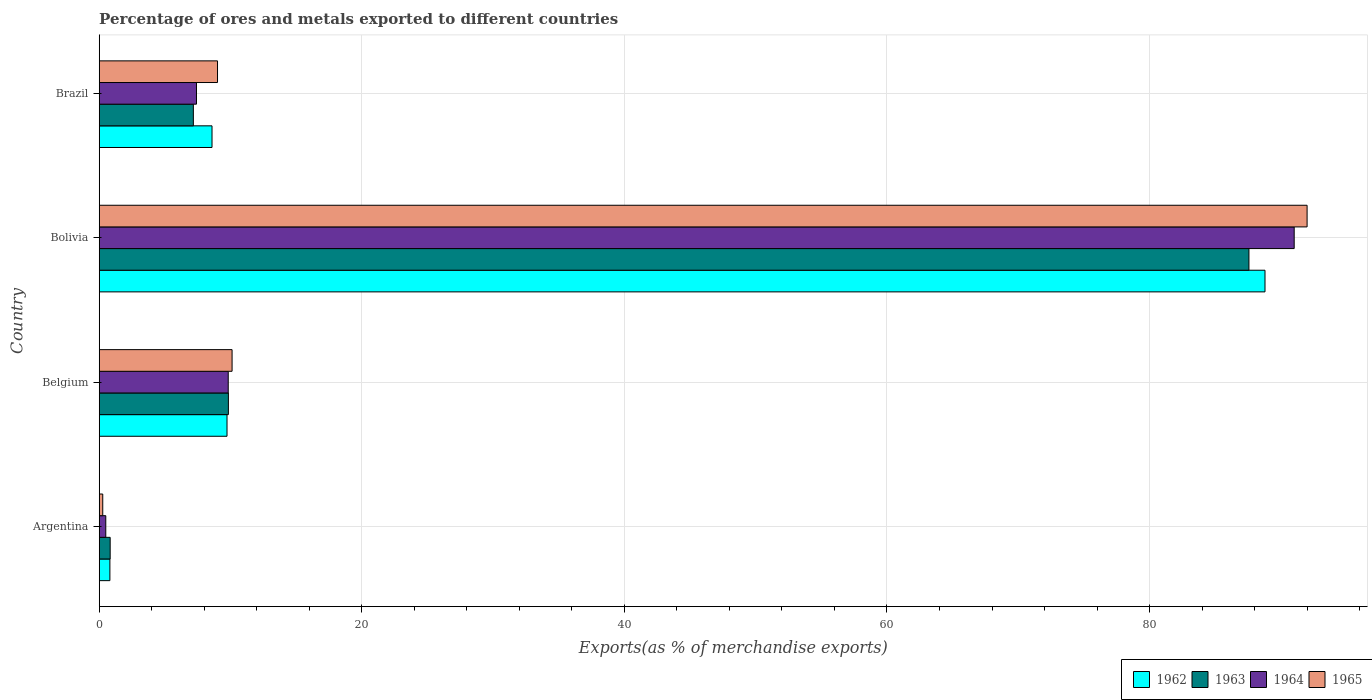How many groups of bars are there?
Offer a very short reply. 4. Are the number of bars per tick equal to the number of legend labels?
Your response must be concise. Yes. Are the number of bars on each tick of the Y-axis equal?
Ensure brevity in your answer.  Yes. How many bars are there on the 3rd tick from the bottom?
Provide a short and direct response. 4. What is the percentage of exports to different countries in 1964 in Argentina?
Offer a terse response. 0.5. Across all countries, what is the maximum percentage of exports to different countries in 1963?
Keep it short and to the point. 87.57. Across all countries, what is the minimum percentage of exports to different countries in 1962?
Give a very brief answer. 0.81. In which country was the percentage of exports to different countries in 1965 maximum?
Offer a terse response. Bolivia. What is the total percentage of exports to different countries in 1964 in the graph?
Ensure brevity in your answer.  108.75. What is the difference between the percentage of exports to different countries in 1965 in Belgium and that in Brazil?
Give a very brief answer. 1.11. What is the difference between the percentage of exports to different countries in 1963 in Bolivia and the percentage of exports to different countries in 1965 in Argentina?
Provide a short and direct response. 87.3. What is the average percentage of exports to different countries in 1962 per country?
Provide a short and direct response. 26.98. What is the difference between the percentage of exports to different countries in 1963 and percentage of exports to different countries in 1964 in Brazil?
Your response must be concise. -0.24. In how many countries, is the percentage of exports to different countries in 1963 greater than 8 %?
Make the answer very short. 2. What is the ratio of the percentage of exports to different countries in 1964 in Belgium to that in Brazil?
Offer a very short reply. 1.33. Is the difference between the percentage of exports to different countries in 1963 in Argentina and Bolivia greater than the difference between the percentage of exports to different countries in 1964 in Argentina and Bolivia?
Keep it short and to the point. Yes. What is the difference between the highest and the second highest percentage of exports to different countries in 1962?
Offer a very short reply. 79.06. What is the difference between the highest and the lowest percentage of exports to different countries in 1965?
Your answer should be compact. 91.73. In how many countries, is the percentage of exports to different countries in 1965 greater than the average percentage of exports to different countries in 1965 taken over all countries?
Provide a short and direct response. 1. Is the sum of the percentage of exports to different countries in 1963 in Argentina and Bolivia greater than the maximum percentage of exports to different countries in 1965 across all countries?
Your answer should be very brief. No. Is it the case that in every country, the sum of the percentage of exports to different countries in 1962 and percentage of exports to different countries in 1964 is greater than the sum of percentage of exports to different countries in 1965 and percentage of exports to different countries in 1963?
Your answer should be compact. No. What does the 1st bar from the top in Argentina represents?
Offer a very short reply. 1965. How many countries are there in the graph?
Give a very brief answer. 4. Does the graph contain any zero values?
Ensure brevity in your answer.  No. Where does the legend appear in the graph?
Offer a terse response. Bottom right. How many legend labels are there?
Offer a terse response. 4. How are the legend labels stacked?
Offer a very short reply. Horizontal. What is the title of the graph?
Ensure brevity in your answer.  Percentage of ores and metals exported to different countries. Does "1960" appear as one of the legend labels in the graph?
Provide a short and direct response. No. What is the label or title of the X-axis?
Your response must be concise. Exports(as % of merchandise exports). What is the Exports(as % of merchandise exports) in 1962 in Argentina?
Give a very brief answer. 0.81. What is the Exports(as % of merchandise exports) in 1963 in Argentina?
Keep it short and to the point. 0.83. What is the Exports(as % of merchandise exports) of 1964 in Argentina?
Your response must be concise. 0.5. What is the Exports(as % of merchandise exports) in 1965 in Argentina?
Your response must be concise. 0.27. What is the Exports(as % of merchandise exports) of 1962 in Belgium?
Give a very brief answer. 9.73. What is the Exports(as % of merchandise exports) in 1963 in Belgium?
Your response must be concise. 9.84. What is the Exports(as % of merchandise exports) in 1964 in Belgium?
Offer a very short reply. 9.83. What is the Exports(as % of merchandise exports) in 1965 in Belgium?
Make the answer very short. 10.12. What is the Exports(as % of merchandise exports) of 1962 in Bolivia?
Ensure brevity in your answer.  88.79. What is the Exports(as % of merchandise exports) in 1963 in Bolivia?
Make the answer very short. 87.57. What is the Exports(as % of merchandise exports) of 1964 in Bolivia?
Your answer should be compact. 91.02. What is the Exports(as % of merchandise exports) in 1965 in Bolivia?
Provide a short and direct response. 92. What is the Exports(as % of merchandise exports) in 1962 in Brazil?
Provide a succinct answer. 8.59. What is the Exports(as % of merchandise exports) of 1963 in Brazil?
Provide a succinct answer. 7.17. What is the Exports(as % of merchandise exports) of 1964 in Brazil?
Provide a succinct answer. 7.41. What is the Exports(as % of merchandise exports) in 1965 in Brazil?
Make the answer very short. 9.01. Across all countries, what is the maximum Exports(as % of merchandise exports) of 1962?
Your answer should be compact. 88.79. Across all countries, what is the maximum Exports(as % of merchandise exports) of 1963?
Your answer should be compact. 87.57. Across all countries, what is the maximum Exports(as % of merchandise exports) in 1964?
Offer a very short reply. 91.02. Across all countries, what is the maximum Exports(as % of merchandise exports) in 1965?
Give a very brief answer. 92. Across all countries, what is the minimum Exports(as % of merchandise exports) of 1962?
Keep it short and to the point. 0.81. Across all countries, what is the minimum Exports(as % of merchandise exports) of 1963?
Your response must be concise. 0.83. Across all countries, what is the minimum Exports(as % of merchandise exports) of 1964?
Ensure brevity in your answer.  0.5. Across all countries, what is the minimum Exports(as % of merchandise exports) in 1965?
Make the answer very short. 0.27. What is the total Exports(as % of merchandise exports) of 1962 in the graph?
Your answer should be very brief. 107.93. What is the total Exports(as % of merchandise exports) in 1963 in the graph?
Make the answer very short. 105.41. What is the total Exports(as % of merchandise exports) in 1964 in the graph?
Ensure brevity in your answer.  108.75. What is the total Exports(as % of merchandise exports) of 1965 in the graph?
Your answer should be very brief. 111.4. What is the difference between the Exports(as % of merchandise exports) in 1962 in Argentina and that in Belgium?
Give a very brief answer. -8.92. What is the difference between the Exports(as % of merchandise exports) of 1963 in Argentina and that in Belgium?
Offer a very short reply. -9. What is the difference between the Exports(as % of merchandise exports) in 1964 in Argentina and that in Belgium?
Give a very brief answer. -9.33. What is the difference between the Exports(as % of merchandise exports) of 1965 in Argentina and that in Belgium?
Make the answer very short. -9.85. What is the difference between the Exports(as % of merchandise exports) in 1962 in Argentina and that in Bolivia?
Provide a succinct answer. -87.98. What is the difference between the Exports(as % of merchandise exports) in 1963 in Argentina and that in Bolivia?
Ensure brevity in your answer.  -86.74. What is the difference between the Exports(as % of merchandise exports) in 1964 in Argentina and that in Bolivia?
Provide a short and direct response. -90.52. What is the difference between the Exports(as % of merchandise exports) in 1965 in Argentina and that in Bolivia?
Give a very brief answer. -91.73. What is the difference between the Exports(as % of merchandise exports) of 1962 in Argentina and that in Brazil?
Offer a terse response. -7.78. What is the difference between the Exports(as % of merchandise exports) in 1963 in Argentina and that in Brazil?
Make the answer very short. -6.34. What is the difference between the Exports(as % of merchandise exports) of 1964 in Argentina and that in Brazil?
Provide a short and direct response. -6.91. What is the difference between the Exports(as % of merchandise exports) of 1965 in Argentina and that in Brazil?
Keep it short and to the point. -8.74. What is the difference between the Exports(as % of merchandise exports) of 1962 in Belgium and that in Bolivia?
Your answer should be very brief. -79.06. What is the difference between the Exports(as % of merchandise exports) of 1963 in Belgium and that in Bolivia?
Provide a short and direct response. -77.73. What is the difference between the Exports(as % of merchandise exports) of 1964 in Belgium and that in Bolivia?
Ensure brevity in your answer.  -81.19. What is the difference between the Exports(as % of merchandise exports) of 1965 in Belgium and that in Bolivia?
Your answer should be compact. -81.88. What is the difference between the Exports(as % of merchandise exports) of 1962 in Belgium and that in Brazil?
Your response must be concise. 1.14. What is the difference between the Exports(as % of merchandise exports) of 1963 in Belgium and that in Brazil?
Provide a short and direct response. 2.67. What is the difference between the Exports(as % of merchandise exports) of 1964 in Belgium and that in Brazil?
Your answer should be compact. 2.42. What is the difference between the Exports(as % of merchandise exports) of 1965 in Belgium and that in Brazil?
Your answer should be very brief. 1.11. What is the difference between the Exports(as % of merchandise exports) of 1962 in Bolivia and that in Brazil?
Your answer should be very brief. 80.2. What is the difference between the Exports(as % of merchandise exports) of 1963 in Bolivia and that in Brazil?
Provide a succinct answer. 80.4. What is the difference between the Exports(as % of merchandise exports) of 1964 in Bolivia and that in Brazil?
Your answer should be very brief. 83.61. What is the difference between the Exports(as % of merchandise exports) of 1965 in Bolivia and that in Brazil?
Your answer should be compact. 82.99. What is the difference between the Exports(as % of merchandise exports) of 1962 in Argentina and the Exports(as % of merchandise exports) of 1963 in Belgium?
Your answer should be very brief. -9.02. What is the difference between the Exports(as % of merchandise exports) in 1962 in Argentina and the Exports(as % of merchandise exports) in 1964 in Belgium?
Give a very brief answer. -9.01. What is the difference between the Exports(as % of merchandise exports) in 1962 in Argentina and the Exports(as % of merchandise exports) in 1965 in Belgium?
Provide a short and direct response. -9.31. What is the difference between the Exports(as % of merchandise exports) of 1963 in Argentina and the Exports(as % of merchandise exports) of 1964 in Belgium?
Keep it short and to the point. -8.99. What is the difference between the Exports(as % of merchandise exports) in 1963 in Argentina and the Exports(as % of merchandise exports) in 1965 in Belgium?
Give a very brief answer. -9.29. What is the difference between the Exports(as % of merchandise exports) in 1964 in Argentina and the Exports(as % of merchandise exports) in 1965 in Belgium?
Your response must be concise. -9.62. What is the difference between the Exports(as % of merchandise exports) of 1962 in Argentina and the Exports(as % of merchandise exports) of 1963 in Bolivia?
Make the answer very short. -86.76. What is the difference between the Exports(as % of merchandise exports) in 1962 in Argentina and the Exports(as % of merchandise exports) in 1964 in Bolivia?
Ensure brevity in your answer.  -90.2. What is the difference between the Exports(as % of merchandise exports) in 1962 in Argentina and the Exports(as % of merchandise exports) in 1965 in Bolivia?
Keep it short and to the point. -91.19. What is the difference between the Exports(as % of merchandise exports) in 1963 in Argentina and the Exports(as % of merchandise exports) in 1964 in Bolivia?
Give a very brief answer. -90.18. What is the difference between the Exports(as % of merchandise exports) in 1963 in Argentina and the Exports(as % of merchandise exports) in 1965 in Bolivia?
Offer a very short reply. -91.17. What is the difference between the Exports(as % of merchandise exports) in 1964 in Argentina and the Exports(as % of merchandise exports) in 1965 in Bolivia?
Make the answer very short. -91.5. What is the difference between the Exports(as % of merchandise exports) in 1962 in Argentina and the Exports(as % of merchandise exports) in 1963 in Brazil?
Ensure brevity in your answer.  -6.36. What is the difference between the Exports(as % of merchandise exports) of 1962 in Argentina and the Exports(as % of merchandise exports) of 1964 in Brazil?
Keep it short and to the point. -6.59. What is the difference between the Exports(as % of merchandise exports) in 1962 in Argentina and the Exports(as % of merchandise exports) in 1965 in Brazil?
Make the answer very short. -8.2. What is the difference between the Exports(as % of merchandise exports) of 1963 in Argentina and the Exports(as % of merchandise exports) of 1964 in Brazil?
Provide a succinct answer. -6.57. What is the difference between the Exports(as % of merchandise exports) in 1963 in Argentina and the Exports(as % of merchandise exports) in 1965 in Brazil?
Offer a terse response. -8.18. What is the difference between the Exports(as % of merchandise exports) in 1964 in Argentina and the Exports(as % of merchandise exports) in 1965 in Brazil?
Ensure brevity in your answer.  -8.51. What is the difference between the Exports(as % of merchandise exports) of 1962 in Belgium and the Exports(as % of merchandise exports) of 1963 in Bolivia?
Make the answer very short. -77.84. What is the difference between the Exports(as % of merchandise exports) in 1962 in Belgium and the Exports(as % of merchandise exports) in 1964 in Bolivia?
Provide a short and direct response. -81.28. What is the difference between the Exports(as % of merchandise exports) in 1962 in Belgium and the Exports(as % of merchandise exports) in 1965 in Bolivia?
Offer a very short reply. -82.27. What is the difference between the Exports(as % of merchandise exports) in 1963 in Belgium and the Exports(as % of merchandise exports) in 1964 in Bolivia?
Give a very brief answer. -81.18. What is the difference between the Exports(as % of merchandise exports) of 1963 in Belgium and the Exports(as % of merchandise exports) of 1965 in Bolivia?
Offer a very short reply. -82.16. What is the difference between the Exports(as % of merchandise exports) of 1964 in Belgium and the Exports(as % of merchandise exports) of 1965 in Bolivia?
Your response must be concise. -82.17. What is the difference between the Exports(as % of merchandise exports) of 1962 in Belgium and the Exports(as % of merchandise exports) of 1963 in Brazil?
Provide a succinct answer. 2.56. What is the difference between the Exports(as % of merchandise exports) in 1962 in Belgium and the Exports(as % of merchandise exports) in 1964 in Brazil?
Provide a succinct answer. 2.33. What is the difference between the Exports(as % of merchandise exports) of 1962 in Belgium and the Exports(as % of merchandise exports) of 1965 in Brazil?
Your response must be concise. 0.72. What is the difference between the Exports(as % of merchandise exports) of 1963 in Belgium and the Exports(as % of merchandise exports) of 1964 in Brazil?
Your response must be concise. 2.43. What is the difference between the Exports(as % of merchandise exports) of 1963 in Belgium and the Exports(as % of merchandise exports) of 1965 in Brazil?
Offer a very short reply. 0.83. What is the difference between the Exports(as % of merchandise exports) of 1964 in Belgium and the Exports(as % of merchandise exports) of 1965 in Brazil?
Your response must be concise. 0.82. What is the difference between the Exports(as % of merchandise exports) in 1962 in Bolivia and the Exports(as % of merchandise exports) in 1963 in Brazil?
Give a very brief answer. 81.62. What is the difference between the Exports(as % of merchandise exports) of 1962 in Bolivia and the Exports(as % of merchandise exports) of 1964 in Brazil?
Your answer should be compact. 81.39. What is the difference between the Exports(as % of merchandise exports) of 1962 in Bolivia and the Exports(as % of merchandise exports) of 1965 in Brazil?
Your answer should be compact. 79.78. What is the difference between the Exports(as % of merchandise exports) of 1963 in Bolivia and the Exports(as % of merchandise exports) of 1964 in Brazil?
Offer a very short reply. 80.16. What is the difference between the Exports(as % of merchandise exports) of 1963 in Bolivia and the Exports(as % of merchandise exports) of 1965 in Brazil?
Provide a succinct answer. 78.56. What is the difference between the Exports(as % of merchandise exports) of 1964 in Bolivia and the Exports(as % of merchandise exports) of 1965 in Brazil?
Your answer should be very brief. 82.01. What is the average Exports(as % of merchandise exports) of 1962 per country?
Ensure brevity in your answer.  26.98. What is the average Exports(as % of merchandise exports) in 1963 per country?
Keep it short and to the point. 26.35. What is the average Exports(as % of merchandise exports) in 1964 per country?
Keep it short and to the point. 27.19. What is the average Exports(as % of merchandise exports) of 1965 per country?
Give a very brief answer. 27.85. What is the difference between the Exports(as % of merchandise exports) of 1962 and Exports(as % of merchandise exports) of 1963 in Argentina?
Provide a succinct answer. -0.02. What is the difference between the Exports(as % of merchandise exports) of 1962 and Exports(as % of merchandise exports) of 1964 in Argentina?
Your response must be concise. 0.31. What is the difference between the Exports(as % of merchandise exports) of 1962 and Exports(as % of merchandise exports) of 1965 in Argentina?
Give a very brief answer. 0.54. What is the difference between the Exports(as % of merchandise exports) of 1963 and Exports(as % of merchandise exports) of 1964 in Argentina?
Ensure brevity in your answer.  0.33. What is the difference between the Exports(as % of merchandise exports) of 1963 and Exports(as % of merchandise exports) of 1965 in Argentina?
Offer a very short reply. 0.56. What is the difference between the Exports(as % of merchandise exports) of 1964 and Exports(as % of merchandise exports) of 1965 in Argentina?
Provide a short and direct response. 0.23. What is the difference between the Exports(as % of merchandise exports) in 1962 and Exports(as % of merchandise exports) in 1963 in Belgium?
Your answer should be compact. -0.1. What is the difference between the Exports(as % of merchandise exports) in 1962 and Exports(as % of merchandise exports) in 1964 in Belgium?
Your answer should be compact. -0.09. What is the difference between the Exports(as % of merchandise exports) of 1962 and Exports(as % of merchandise exports) of 1965 in Belgium?
Keep it short and to the point. -0.39. What is the difference between the Exports(as % of merchandise exports) of 1963 and Exports(as % of merchandise exports) of 1964 in Belgium?
Your answer should be very brief. 0.01. What is the difference between the Exports(as % of merchandise exports) in 1963 and Exports(as % of merchandise exports) in 1965 in Belgium?
Offer a terse response. -0.28. What is the difference between the Exports(as % of merchandise exports) in 1964 and Exports(as % of merchandise exports) in 1965 in Belgium?
Ensure brevity in your answer.  -0.29. What is the difference between the Exports(as % of merchandise exports) in 1962 and Exports(as % of merchandise exports) in 1963 in Bolivia?
Provide a succinct answer. 1.22. What is the difference between the Exports(as % of merchandise exports) in 1962 and Exports(as % of merchandise exports) in 1964 in Bolivia?
Provide a succinct answer. -2.22. What is the difference between the Exports(as % of merchandise exports) in 1962 and Exports(as % of merchandise exports) in 1965 in Bolivia?
Make the answer very short. -3.21. What is the difference between the Exports(as % of merchandise exports) in 1963 and Exports(as % of merchandise exports) in 1964 in Bolivia?
Your answer should be compact. -3.45. What is the difference between the Exports(as % of merchandise exports) in 1963 and Exports(as % of merchandise exports) in 1965 in Bolivia?
Provide a succinct answer. -4.43. What is the difference between the Exports(as % of merchandise exports) in 1964 and Exports(as % of merchandise exports) in 1965 in Bolivia?
Your answer should be compact. -0.98. What is the difference between the Exports(as % of merchandise exports) of 1962 and Exports(as % of merchandise exports) of 1963 in Brazil?
Offer a very short reply. 1.42. What is the difference between the Exports(as % of merchandise exports) in 1962 and Exports(as % of merchandise exports) in 1964 in Brazil?
Your answer should be compact. 1.18. What is the difference between the Exports(as % of merchandise exports) in 1962 and Exports(as % of merchandise exports) in 1965 in Brazil?
Ensure brevity in your answer.  -0.42. What is the difference between the Exports(as % of merchandise exports) of 1963 and Exports(as % of merchandise exports) of 1964 in Brazil?
Your answer should be very brief. -0.24. What is the difference between the Exports(as % of merchandise exports) in 1963 and Exports(as % of merchandise exports) in 1965 in Brazil?
Give a very brief answer. -1.84. What is the difference between the Exports(as % of merchandise exports) of 1964 and Exports(as % of merchandise exports) of 1965 in Brazil?
Offer a very short reply. -1.6. What is the ratio of the Exports(as % of merchandise exports) in 1962 in Argentina to that in Belgium?
Provide a succinct answer. 0.08. What is the ratio of the Exports(as % of merchandise exports) of 1963 in Argentina to that in Belgium?
Ensure brevity in your answer.  0.08. What is the ratio of the Exports(as % of merchandise exports) in 1964 in Argentina to that in Belgium?
Your answer should be compact. 0.05. What is the ratio of the Exports(as % of merchandise exports) in 1965 in Argentina to that in Belgium?
Your response must be concise. 0.03. What is the ratio of the Exports(as % of merchandise exports) in 1962 in Argentina to that in Bolivia?
Offer a very short reply. 0.01. What is the ratio of the Exports(as % of merchandise exports) in 1963 in Argentina to that in Bolivia?
Keep it short and to the point. 0.01. What is the ratio of the Exports(as % of merchandise exports) in 1964 in Argentina to that in Bolivia?
Your response must be concise. 0.01. What is the ratio of the Exports(as % of merchandise exports) of 1965 in Argentina to that in Bolivia?
Your response must be concise. 0. What is the ratio of the Exports(as % of merchandise exports) of 1962 in Argentina to that in Brazil?
Ensure brevity in your answer.  0.09. What is the ratio of the Exports(as % of merchandise exports) of 1963 in Argentina to that in Brazil?
Offer a very short reply. 0.12. What is the ratio of the Exports(as % of merchandise exports) in 1964 in Argentina to that in Brazil?
Ensure brevity in your answer.  0.07. What is the ratio of the Exports(as % of merchandise exports) of 1965 in Argentina to that in Brazil?
Provide a short and direct response. 0.03. What is the ratio of the Exports(as % of merchandise exports) of 1962 in Belgium to that in Bolivia?
Offer a very short reply. 0.11. What is the ratio of the Exports(as % of merchandise exports) of 1963 in Belgium to that in Bolivia?
Your answer should be very brief. 0.11. What is the ratio of the Exports(as % of merchandise exports) in 1964 in Belgium to that in Bolivia?
Your answer should be very brief. 0.11. What is the ratio of the Exports(as % of merchandise exports) in 1965 in Belgium to that in Bolivia?
Offer a terse response. 0.11. What is the ratio of the Exports(as % of merchandise exports) in 1962 in Belgium to that in Brazil?
Make the answer very short. 1.13. What is the ratio of the Exports(as % of merchandise exports) in 1963 in Belgium to that in Brazil?
Your answer should be compact. 1.37. What is the ratio of the Exports(as % of merchandise exports) of 1964 in Belgium to that in Brazil?
Offer a very short reply. 1.33. What is the ratio of the Exports(as % of merchandise exports) of 1965 in Belgium to that in Brazil?
Offer a very short reply. 1.12. What is the ratio of the Exports(as % of merchandise exports) of 1962 in Bolivia to that in Brazil?
Ensure brevity in your answer.  10.33. What is the ratio of the Exports(as % of merchandise exports) in 1963 in Bolivia to that in Brazil?
Your answer should be compact. 12.21. What is the ratio of the Exports(as % of merchandise exports) of 1964 in Bolivia to that in Brazil?
Offer a very short reply. 12.29. What is the ratio of the Exports(as % of merchandise exports) in 1965 in Bolivia to that in Brazil?
Offer a terse response. 10.21. What is the difference between the highest and the second highest Exports(as % of merchandise exports) of 1962?
Ensure brevity in your answer.  79.06. What is the difference between the highest and the second highest Exports(as % of merchandise exports) in 1963?
Your answer should be compact. 77.73. What is the difference between the highest and the second highest Exports(as % of merchandise exports) in 1964?
Offer a terse response. 81.19. What is the difference between the highest and the second highest Exports(as % of merchandise exports) of 1965?
Keep it short and to the point. 81.88. What is the difference between the highest and the lowest Exports(as % of merchandise exports) of 1962?
Make the answer very short. 87.98. What is the difference between the highest and the lowest Exports(as % of merchandise exports) in 1963?
Your answer should be compact. 86.74. What is the difference between the highest and the lowest Exports(as % of merchandise exports) of 1964?
Your answer should be compact. 90.52. What is the difference between the highest and the lowest Exports(as % of merchandise exports) of 1965?
Offer a terse response. 91.73. 